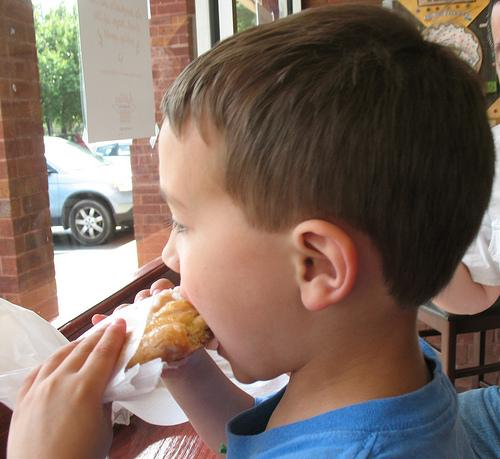Describe the scene depicted in the image in terms of the setting and the subjects present. The scene takes place during the daytime, inside a restaurant with a little boy wearing a blue shirt, a car parked in the parking lot, and red bricks on columns. What is the boy in the image wearing and what is the color of his shirt? The boy in the image is wearing a blue t-shirt. How many red bricks can you find making up beams in the image? There are 7 instances of small red bricks making a beam. 